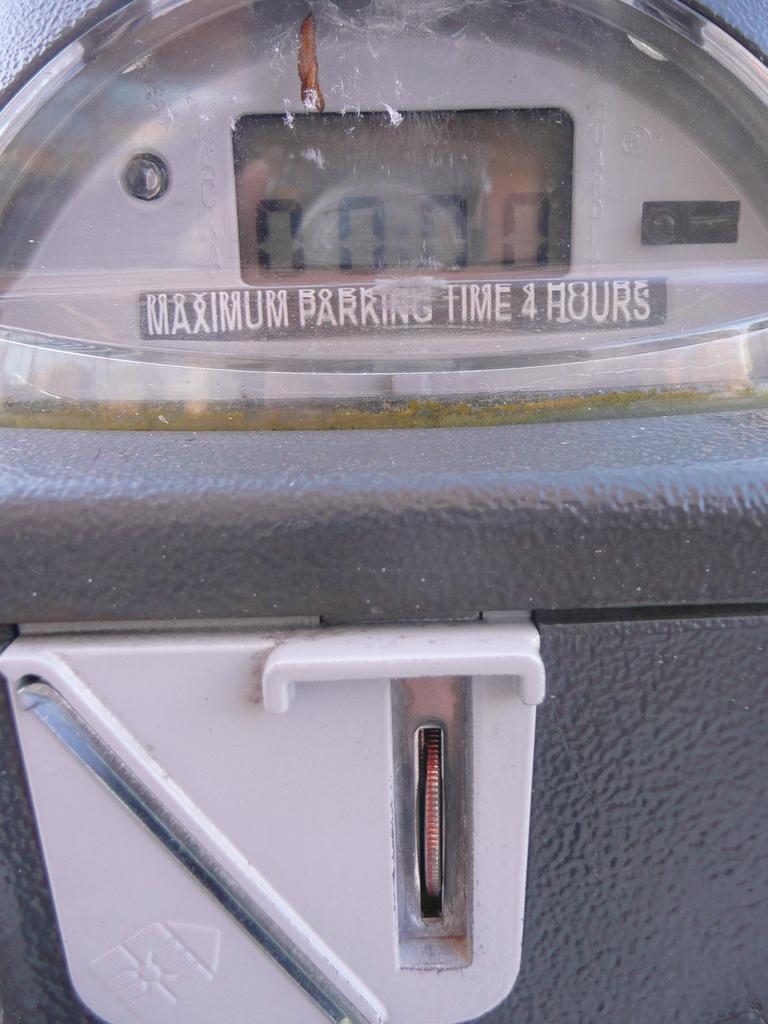What is the maximum parking time?
Keep it short and to the point. 4 hours. Can you park for 4 hours?
Your response must be concise. Yes. 